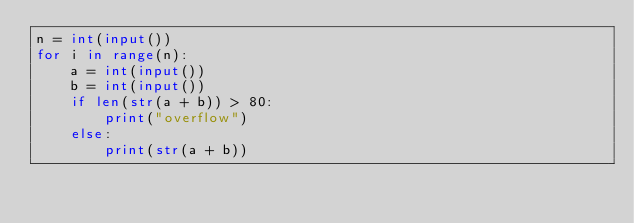<code> <loc_0><loc_0><loc_500><loc_500><_Python_>n = int(input())
for i in range(n):
    a = int(input())
    b = int(input())
    if len(str(a + b)) > 80:
        print("overflow")
    else:
        print(str(a + b))</code> 